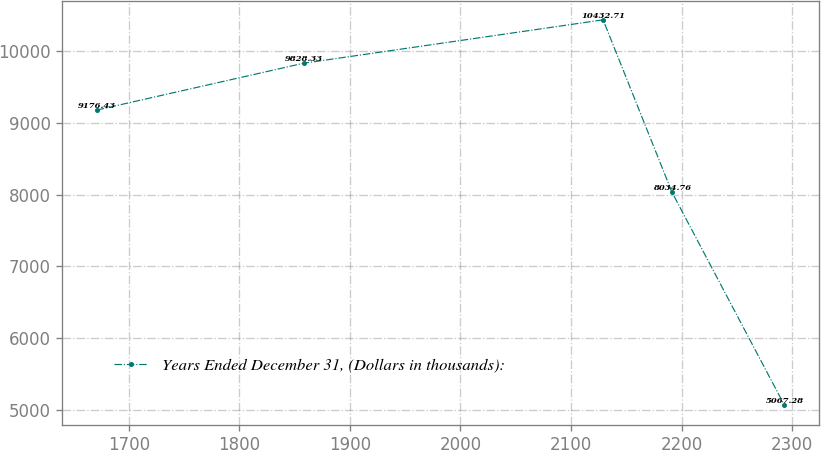Convert chart to OTSL. <chart><loc_0><loc_0><loc_500><loc_500><line_chart><ecel><fcel>Years Ended December 31, (Dollars in thousands):<nl><fcel>1670.99<fcel>9176.43<nl><fcel>1858.08<fcel>9828.33<nl><fcel>2129.07<fcel>10432.7<nl><fcel>2191.28<fcel>8034.76<nl><fcel>2293.07<fcel>5067.28<nl></chart> 